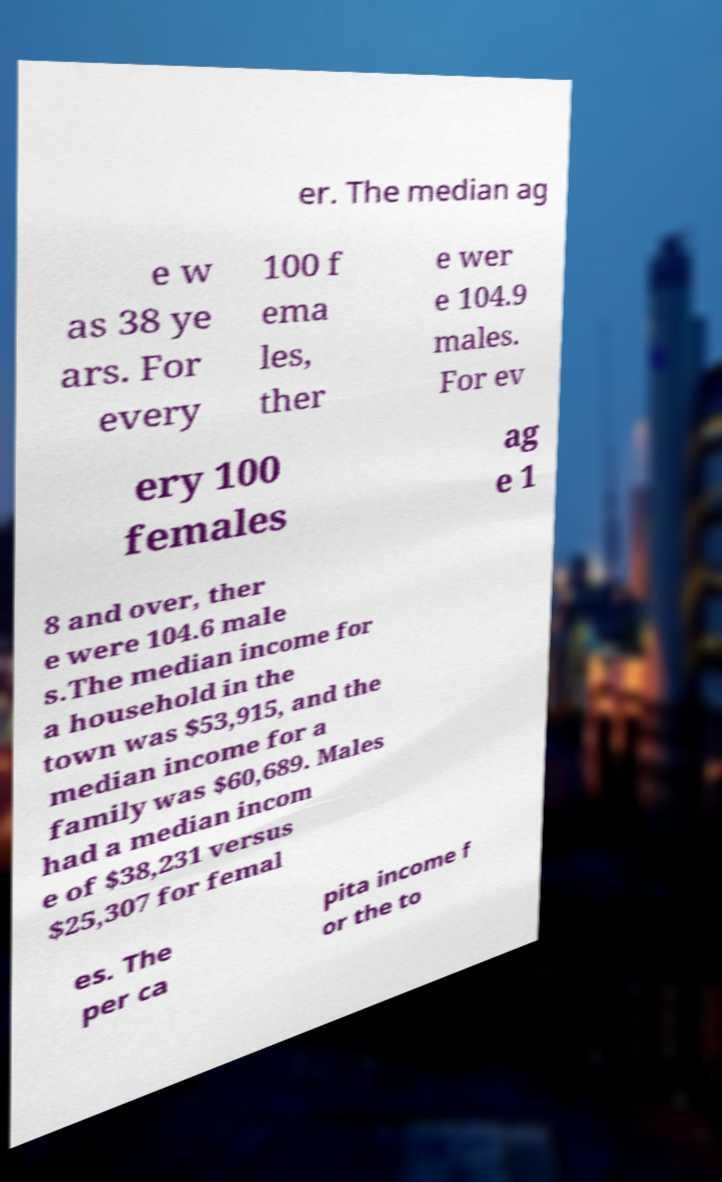Can you read and provide the text displayed in the image?This photo seems to have some interesting text. Can you extract and type it out for me? er. The median ag e w as 38 ye ars. For every 100 f ema les, ther e wer e 104.9 males. For ev ery 100 females ag e 1 8 and over, ther e were 104.6 male s.The median income for a household in the town was $53,915, and the median income for a family was $60,689. Males had a median incom e of $38,231 versus $25,307 for femal es. The per ca pita income f or the to 